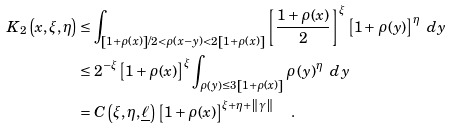<formula> <loc_0><loc_0><loc_500><loc_500>K _ { 2 } \left ( x , \xi , \eta \right ) & \leq \int _ { \left [ 1 + \rho ( x ) \right ] / 2 < \rho \left ( x - y \right ) < 2 \left [ 1 + \rho ( x ) \right ] } \left [ \frac { 1 + \rho ( x ) } { 2 } \right ] ^ { \xi } \left [ 1 + \rho ( y ) \right ] ^ { \eta } \ d y \\ & \leq 2 ^ { - \xi } \left [ 1 + \rho ( x ) \right ] ^ { \xi } \int _ { \rho \left ( y \right ) \leq 3 \left [ 1 + \rho ( x ) \right ] } \rho \left ( y \right ) ^ { \eta } \ d y \\ & = C \left ( \xi , \eta , \underline { \ell } \right ) \left [ 1 + \rho ( x ) \right ] ^ { \xi + \eta + \left \| \gamma \right \| } \quad .</formula> 